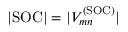Convert formula to latex. <formula><loc_0><loc_0><loc_500><loc_500>| S O C | = | V _ { m n } ^ { ( S O C ) } |</formula> 